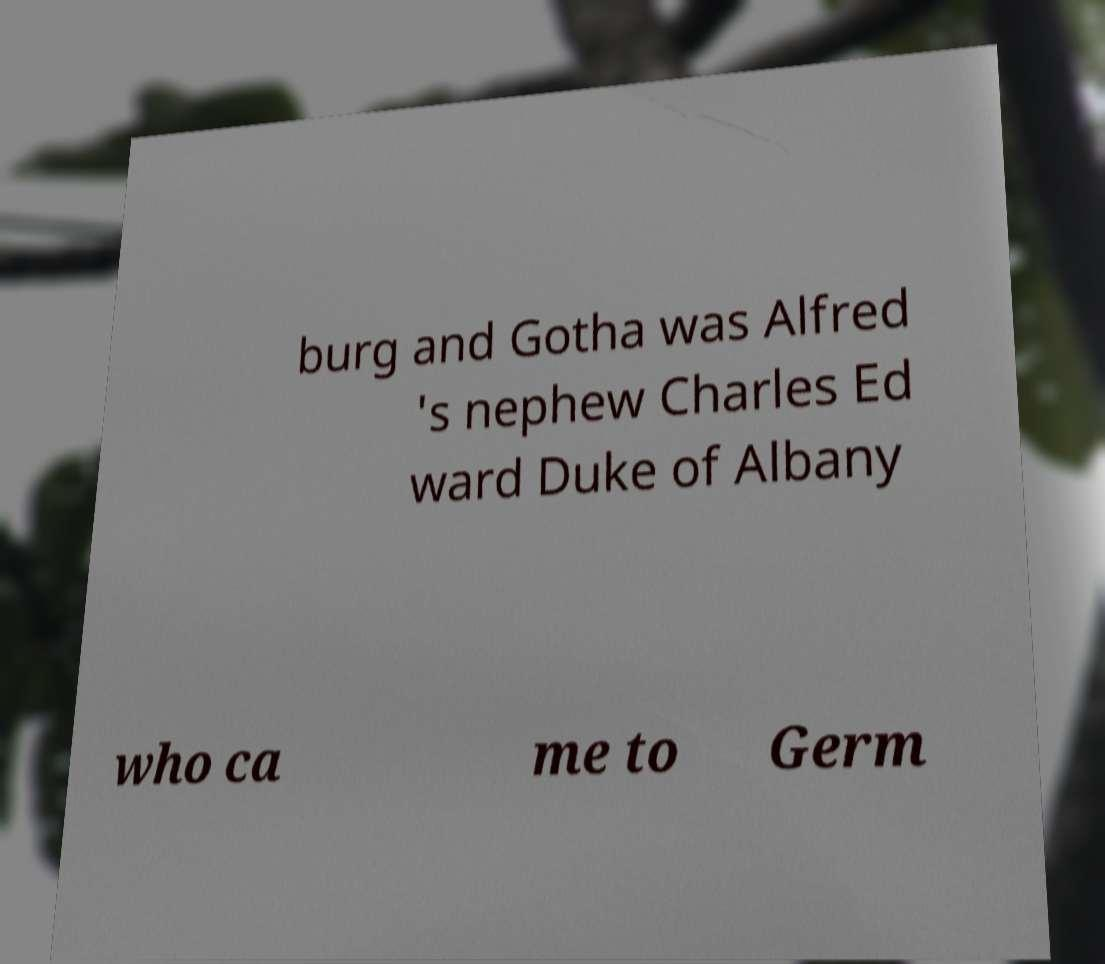For documentation purposes, I need the text within this image transcribed. Could you provide that? burg and Gotha was Alfred 's nephew Charles Ed ward Duke of Albany who ca me to Germ 